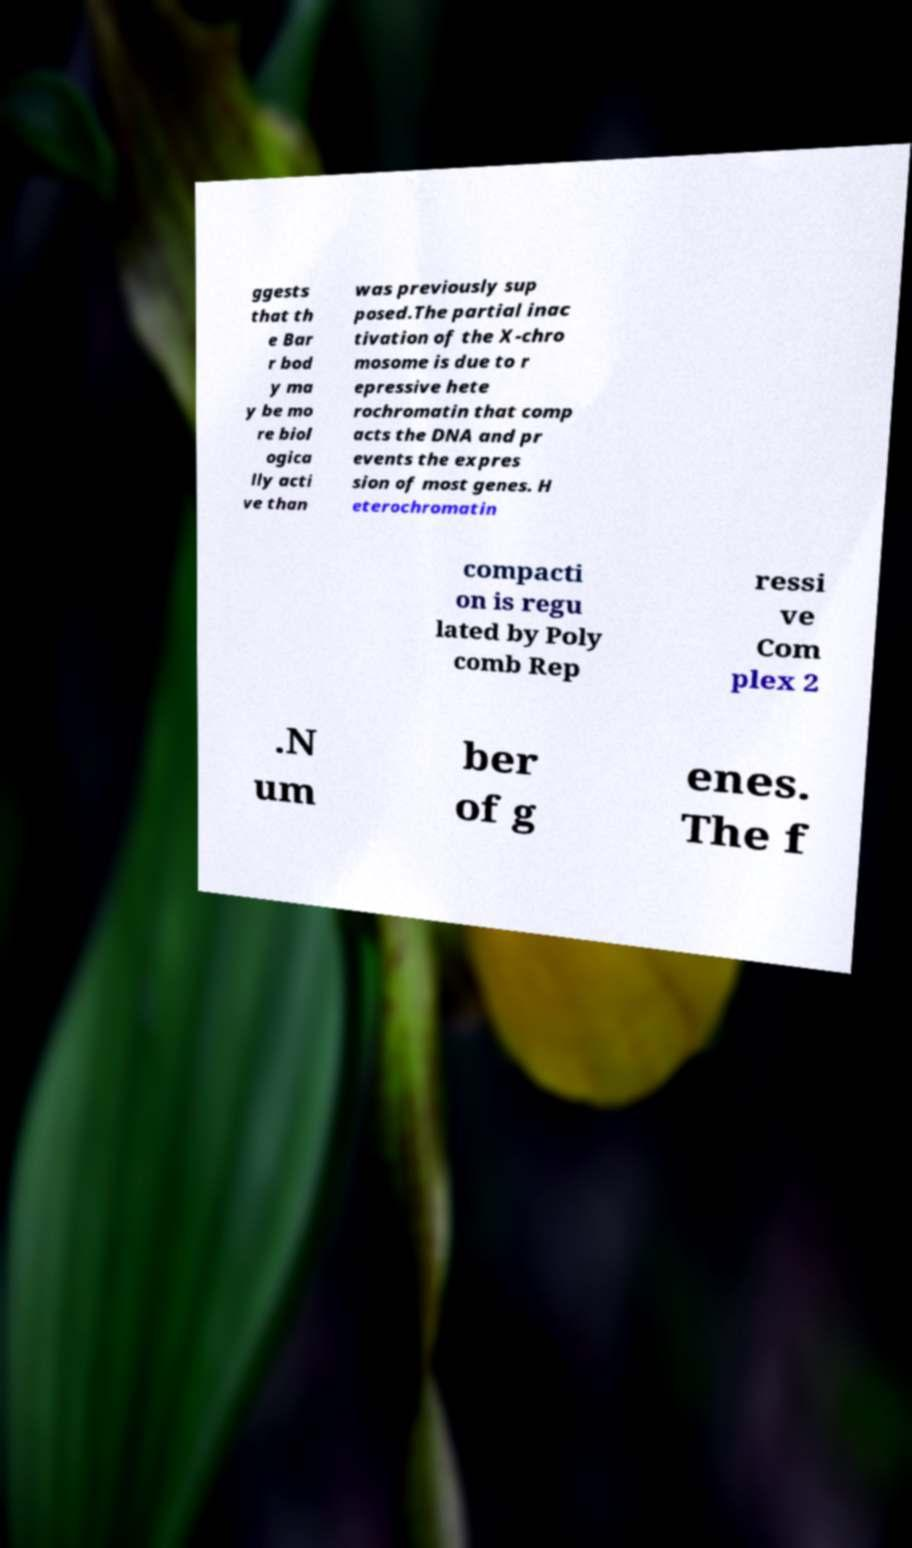Could you assist in decoding the text presented in this image and type it out clearly? ggests that th e Bar r bod y ma y be mo re biol ogica lly acti ve than was previously sup posed.The partial inac tivation of the X-chro mosome is due to r epressive hete rochromatin that comp acts the DNA and pr events the expres sion of most genes. H eterochromatin compacti on is regu lated by Poly comb Rep ressi ve Com plex 2 .N um ber of g enes. The f 